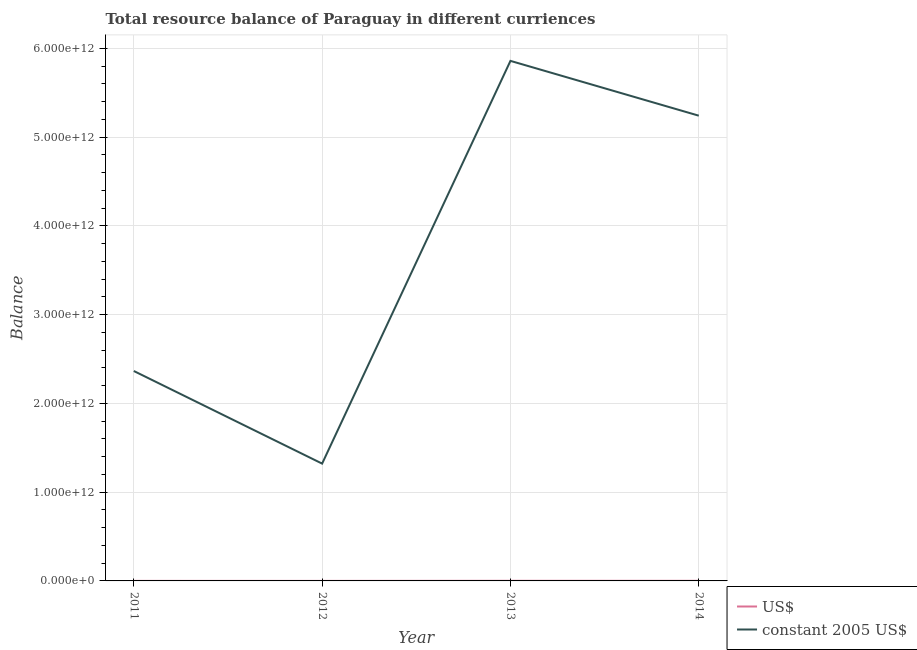Does the line corresponding to resource balance in us$ intersect with the line corresponding to resource balance in constant us$?
Make the answer very short. No. What is the resource balance in constant us$ in 2014?
Your answer should be very brief. 5.24e+12. Across all years, what is the maximum resource balance in us$?
Your answer should be compact. 1.36e+09. Across all years, what is the minimum resource balance in constant us$?
Keep it short and to the point. 1.32e+12. In which year was the resource balance in constant us$ minimum?
Ensure brevity in your answer.  2012. What is the total resource balance in constant us$ in the graph?
Your answer should be very brief. 1.48e+13. What is the difference between the resource balance in constant us$ in 2013 and that in 2014?
Ensure brevity in your answer.  6.17e+11. What is the difference between the resource balance in us$ in 2011 and the resource balance in constant us$ in 2012?
Offer a terse response. -1.32e+12. What is the average resource balance in constant us$ per year?
Ensure brevity in your answer.  3.70e+12. In the year 2012, what is the difference between the resource balance in constant us$ and resource balance in us$?
Make the answer very short. 1.32e+12. What is the ratio of the resource balance in constant us$ in 2011 to that in 2014?
Your response must be concise. 0.45. Is the resource balance in constant us$ in 2011 less than that in 2013?
Provide a short and direct response. Yes. What is the difference between the highest and the second highest resource balance in constant us$?
Provide a short and direct response. 6.17e+11. What is the difference between the highest and the lowest resource balance in constant us$?
Make the answer very short. 4.54e+12. In how many years, is the resource balance in us$ greater than the average resource balance in us$ taken over all years?
Provide a short and direct response. 2. Is the sum of the resource balance in constant us$ in 2011 and 2013 greater than the maximum resource balance in us$ across all years?
Provide a succinct answer. Yes. How many lines are there?
Provide a short and direct response. 2. What is the difference between two consecutive major ticks on the Y-axis?
Make the answer very short. 1.00e+12. Does the graph contain any zero values?
Offer a terse response. No. Where does the legend appear in the graph?
Your answer should be very brief. Bottom right. What is the title of the graph?
Ensure brevity in your answer.  Total resource balance of Paraguay in different curriences. Does "Private credit bureau" appear as one of the legend labels in the graph?
Your response must be concise. No. What is the label or title of the Y-axis?
Your response must be concise. Balance. What is the Balance in US$ in 2011?
Ensure brevity in your answer.  5.64e+08. What is the Balance in constant 2005 US$ in 2011?
Offer a very short reply. 2.37e+12. What is the Balance in US$ in 2012?
Your response must be concise. 2.99e+08. What is the Balance of constant 2005 US$ in 2012?
Your answer should be very brief. 1.32e+12. What is the Balance of US$ in 2013?
Your response must be concise. 1.36e+09. What is the Balance of constant 2005 US$ in 2013?
Make the answer very short. 5.86e+12. What is the Balance of US$ in 2014?
Make the answer very short. 1.17e+09. What is the Balance of constant 2005 US$ in 2014?
Your response must be concise. 5.24e+12. Across all years, what is the maximum Balance in US$?
Offer a very short reply. 1.36e+09. Across all years, what is the maximum Balance of constant 2005 US$?
Give a very brief answer. 5.86e+12. Across all years, what is the minimum Balance of US$?
Ensure brevity in your answer.  2.99e+08. Across all years, what is the minimum Balance of constant 2005 US$?
Ensure brevity in your answer.  1.32e+12. What is the total Balance of US$ in the graph?
Your response must be concise. 3.40e+09. What is the total Balance of constant 2005 US$ in the graph?
Your response must be concise. 1.48e+13. What is the difference between the Balance in US$ in 2011 and that in 2012?
Make the answer very short. 2.65e+08. What is the difference between the Balance of constant 2005 US$ in 2011 and that in 2012?
Offer a very short reply. 1.04e+12. What is the difference between the Balance in US$ in 2011 and that in 2013?
Your answer should be very brief. -7.98e+08. What is the difference between the Balance of constant 2005 US$ in 2011 and that in 2013?
Give a very brief answer. -3.49e+12. What is the difference between the Balance in US$ in 2011 and that in 2014?
Give a very brief answer. -6.11e+08. What is the difference between the Balance in constant 2005 US$ in 2011 and that in 2014?
Make the answer very short. -2.88e+12. What is the difference between the Balance in US$ in 2012 and that in 2013?
Offer a terse response. -1.06e+09. What is the difference between the Balance in constant 2005 US$ in 2012 and that in 2013?
Give a very brief answer. -4.54e+12. What is the difference between the Balance of US$ in 2012 and that in 2014?
Offer a terse response. -8.76e+08. What is the difference between the Balance of constant 2005 US$ in 2012 and that in 2014?
Provide a short and direct response. -3.92e+12. What is the difference between the Balance in US$ in 2013 and that in 2014?
Your answer should be very brief. 1.87e+08. What is the difference between the Balance in constant 2005 US$ in 2013 and that in 2014?
Your response must be concise. 6.17e+11. What is the difference between the Balance in US$ in 2011 and the Balance in constant 2005 US$ in 2012?
Your answer should be compact. -1.32e+12. What is the difference between the Balance in US$ in 2011 and the Balance in constant 2005 US$ in 2013?
Your response must be concise. -5.86e+12. What is the difference between the Balance of US$ in 2011 and the Balance of constant 2005 US$ in 2014?
Ensure brevity in your answer.  -5.24e+12. What is the difference between the Balance in US$ in 2012 and the Balance in constant 2005 US$ in 2013?
Your answer should be compact. -5.86e+12. What is the difference between the Balance in US$ in 2012 and the Balance in constant 2005 US$ in 2014?
Your response must be concise. -5.24e+12. What is the difference between the Balance in US$ in 2013 and the Balance in constant 2005 US$ in 2014?
Keep it short and to the point. -5.24e+12. What is the average Balance in US$ per year?
Give a very brief answer. 8.50e+08. What is the average Balance in constant 2005 US$ per year?
Make the answer very short. 3.70e+12. In the year 2011, what is the difference between the Balance in US$ and Balance in constant 2005 US$?
Offer a very short reply. -2.36e+12. In the year 2012, what is the difference between the Balance of US$ and Balance of constant 2005 US$?
Offer a very short reply. -1.32e+12. In the year 2013, what is the difference between the Balance of US$ and Balance of constant 2005 US$?
Ensure brevity in your answer.  -5.86e+12. In the year 2014, what is the difference between the Balance in US$ and Balance in constant 2005 US$?
Your response must be concise. -5.24e+12. What is the ratio of the Balance in US$ in 2011 to that in 2012?
Give a very brief answer. 1.89. What is the ratio of the Balance in constant 2005 US$ in 2011 to that in 2012?
Make the answer very short. 1.79. What is the ratio of the Balance in US$ in 2011 to that in 2013?
Offer a very short reply. 0.41. What is the ratio of the Balance of constant 2005 US$ in 2011 to that in 2013?
Your answer should be compact. 0.4. What is the ratio of the Balance of US$ in 2011 to that in 2014?
Provide a short and direct response. 0.48. What is the ratio of the Balance in constant 2005 US$ in 2011 to that in 2014?
Give a very brief answer. 0.45. What is the ratio of the Balance in US$ in 2012 to that in 2013?
Your response must be concise. 0.22. What is the ratio of the Balance in constant 2005 US$ in 2012 to that in 2013?
Provide a succinct answer. 0.23. What is the ratio of the Balance in US$ in 2012 to that in 2014?
Make the answer very short. 0.25. What is the ratio of the Balance of constant 2005 US$ in 2012 to that in 2014?
Ensure brevity in your answer.  0.25. What is the ratio of the Balance in US$ in 2013 to that in 2014?
Your answer should be compact. 1.16. What is the ratio of the Balance in constant 2005 US$ in 2013 to that in 2014?
Make the answer very short. 1.12. What is the difference between the highest and the second highest Balance of US$?
Keep it short and to the point. 1.87e+08. What is the difference between the highest and the second highest Balance in constant 2005 US$?
Ensure brevity in your answer.  6.17e+11. What is the difference between the highest and the lowest Balance of US$?
Keep it short and to the point. 1.06e+09. What is the difference between the highest and the lowest Balance in constant 2005 US$?
Keep it short and to the point. 4.54e+12. 